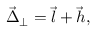<formula> <loc_0><loc_0><loc_500><loc_500>\vec { \Delta } _ { \perp } = \vec { l } + \vec { h } ,</formula> 